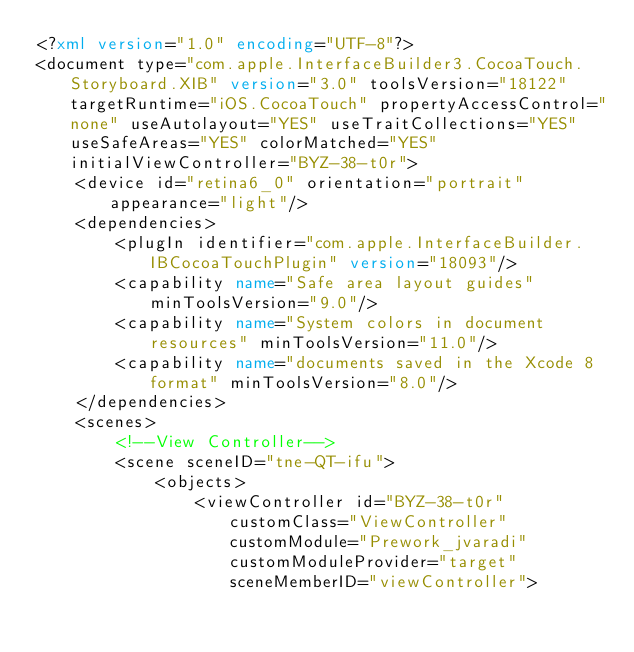Convert code to text. <code><loc_0><loc_0><loc_500><loc_500><_XML_><?xml version="1.0" encoding="UTF-8"?>
<document type="com.apple.InterfaceBuilder3.CocoaTouch.Storyboard.XIB" version="3.0" toolsVersion="18122" targetRuntime="iOS.CocoaTouch" propertyAccessControl="none" useAutolayout="YES" useTraitCollections="YES" useSafeAreas="YES" colorMatched="YES" initialViewController="BYZ-38-t0r">
    <device id="retina6_0" orientation="portrait" appearance="light"/>
    <dependencies>
        <plugIn identifier="com.apple.InterfaceBuilder.IBCocoaTouchPlugin" version="18093"/>
        <capability name="Safe area layout guides" minToolsVersion="9.0"/>
        <capability name="System colors in document resources" minToolsVersion="11.0"/>
        <capability name="documents saved in the Xcode 8 format" minToolsVersion="8.0"/>
    </dependencies>
    <scenes>
        <!--View Controller-->
        <scene sceneID="tne-QT-ifu">
            <objects>
                <viewController id="BYZ-38-t0r" customClass="ViewController" customModule="Prework_jvaradi" customModuleProvider="target" sceneMemberID="viewController"></code> 